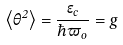<formula> <loc_0><loc_0><loc_500><loc_500>\left \langle \theta ^ { 2 } \right \rangle = \frac { { \epsilon } _ { c } } { \hbar { \varpi } _ { o } } = g</formula> 